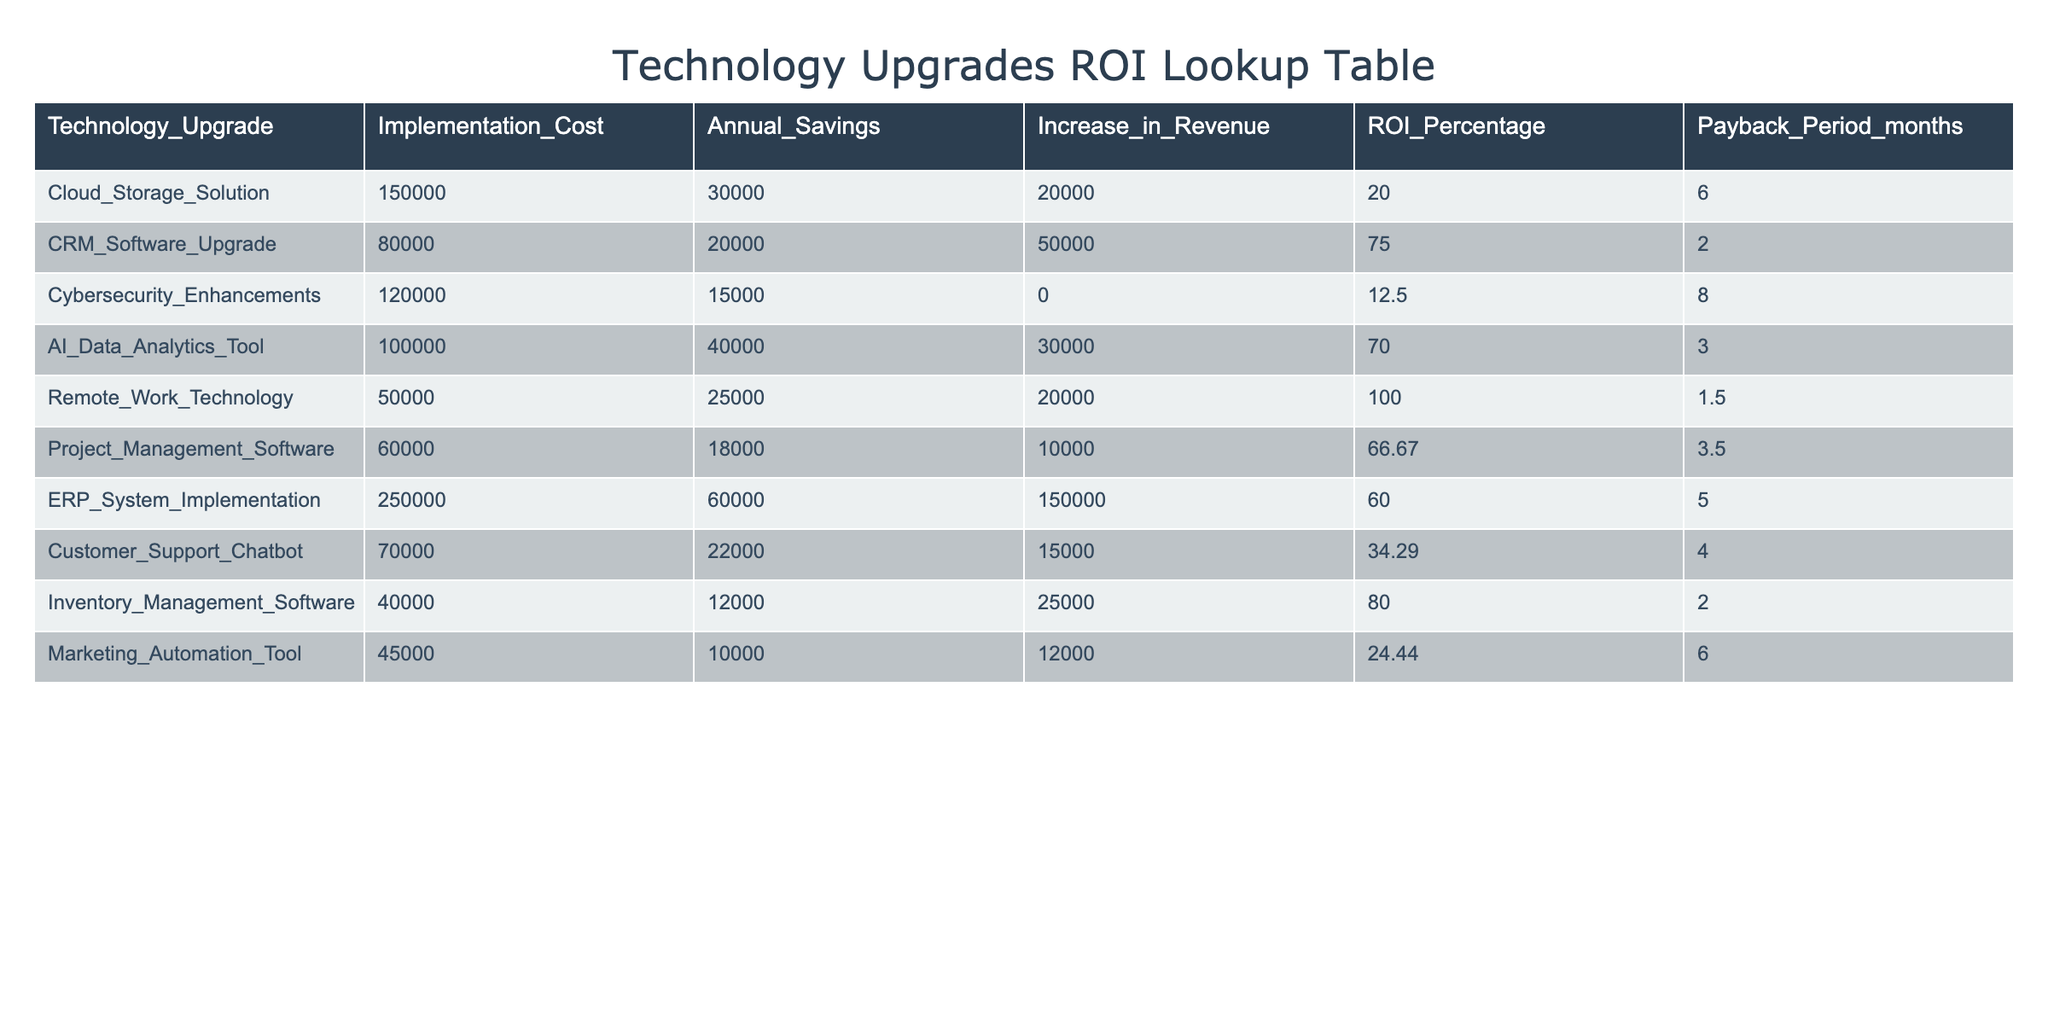What is the ROI percentage for the CRM Software Upgrade? The table shows that the ROI percentage for the CRM Software Upgrade is listed directly under the "ROI_Percentage" column. It is clearly shown as 75.
Answer: 75 Which technology upgrade has the shortest payback period? By examining the "Payback_Period_months" column, we can see that the Remote Work Technology has the shortest payback period at 1.5 months, which is less than all other values in the column.
Answer: 1.5 months What is the total annual savings from the Cloud Storage Solution and AI Data Analytics Tool? We need to add the annual savings from both technologies. The Cloud Storage Solution has annual savings of 30,000 and the AI Data Analytics Tool has annual savings of 40,000. Adding these gives us 30,000 + 40,000 = 70,000.
Answer: 70,000 Is the increase in revenue for Cybersecurity Enhancements greater than 10,000? The increase in revenue for Cybersecurity Enhancements is listed as 0. Since 0 is not greater than 10,000, the answer is no.
Answer: No If we average the ROI percentages of all the technology upgrades, what will it be? To find the average ROI, first, we sum all the ROI percentages: 20 + 75 + 12.5 + 70 + 100 + 66.67 + 60 + 34.29 + 80 + 24.44 =  512.90. Next, we divide by the number of upgrades (10): 512.90 / 10 = 51.29.
Answer: 51.29 Which technology upgrade offers the highest increase in revenue? Looking at the "Increase_in_Revenue" column, we find that the ERP System Implementation offers the highest increase in revenue at 150,000 compared to all other values.
Answer: 150,000 Is the implementation cost for the Inventory Management Software less than the average implementation cost across all upgrades? The average implementation cost is calculated by summing all implementation costs: 150000 + 80000 + 120000 + 100000 + 50000 + 60000 + 250000 + 70000 + 40000 + 45000 =  1,030,000, then dividing by 10, which equals 103,000. The cost for Inventory Management Software is 40,000, which is less than 103,000.
Answer: Yes What is the combined payback period for the Remote Work Technology and Inventory Management Software? The payback periods for Remote Work Technology and Inventory Management Software are 1.5 months and 2 months, respectively. Adding these values gives us 1.5 + 2 = 3.5 months as the combined payback period.
Answer: 3.5 months 